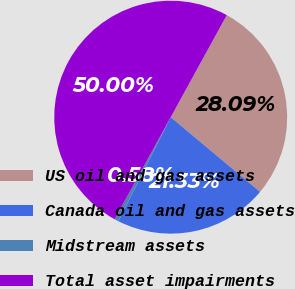Convert chart to OTSL. <chart><loc_0><loc_0><loc_500><loc_500><pie_chart><fcel>US oil and gas assets<fcel>Canada oil and gas assets<fcel>Midstream assets<fcel>Total asset impairments<nl><fcel>28.09%<fcel>21.33%<fcel>0.58%<fcel>50.0%<nl></chart> 